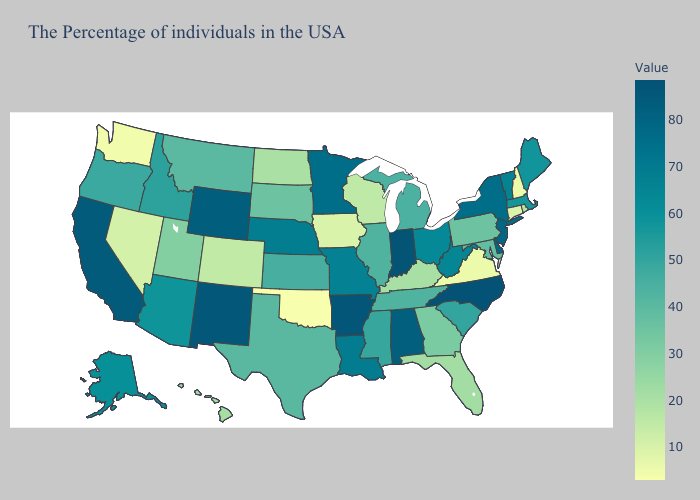Which states have the lowest value in the USA?
Keep it brief. Oklahoma. Does Washington have the lowest value in the West?
Be succinct. Yes. Is the legend a continuous bar?
Short answer required. Yes. Which states have the highest value in the USA?
Short answer required. North Carolina. 